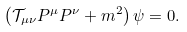<formula> <loc_0><loc_0><loc_500><loc_500>\left ( \mathcal { T } _ { \mu \nu } P ^ { \mu } P ^ { \nu } + m ^ { 2 } \right ) \psi = 0 .</formula> 